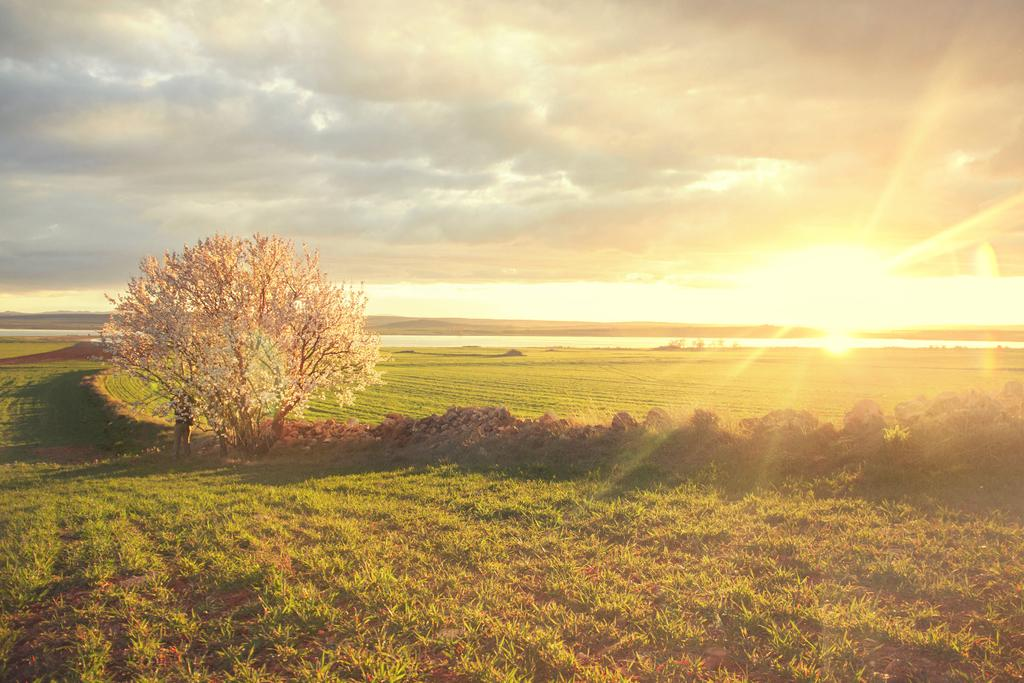What type of vegetation is present on the ground in the image? There is grass on the ground in the image. What other natural elements can be seen in the image? There is a tree and plants on the path in the image. What is visible in the sky in the image? Sun rays are visible in the sky, and the sky is cloudy. How many pigs are visible in the image? There are no pigs present in the image. What type of steel structure can be seen in the image? There is no steel structure present in the image. 